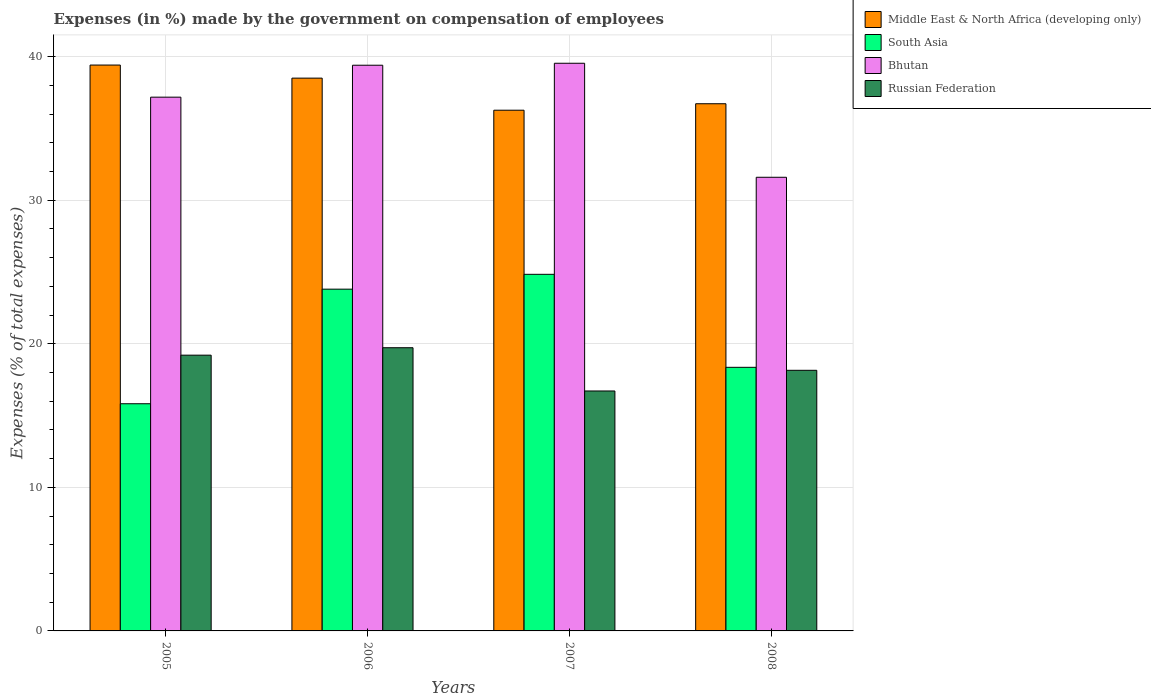How many different coloured bars are there?
Your answer should be very brief. 4. Are the number of bars per tick equal to the number of legend labels?
Give a very brief answer. Yes. Are the number of bars on each tick of the X-axis equal?
Provide a succinct answer. Yes. How many bars are there on the 4th tick from the right?
Your answer should be compact. 4. In how many cases, is the number of bars for a given year not equal to the number of legend labels?
Offer a very short reply. 0. What is the percentage of expenses made by the government on compensation of employees in Russian Federation in 2005?
Make the answer very short. 19.21. Across all years, what is the maximum percentage of expenses made by the government on compensation of employees in Bhutan?
Offer a terse response. 39.54. Across all years, what is the minimum percentage of expenses made by the government on compensation of employees in South Asia?
Offer a very short reply. 15.82. In which year was the percentage of expenses made by the government on compensation of employees in Bhutan maximum?
Make the answer very short. 2007. In which year was the percentage of expenses made by the government on compensation of employees in Bhutan minimum?
Your answer should be very brief. 2008. What is the total percentage of expenses made by the government on compensation of employees in Russian Federation in the graph?
Provide a succinct answer. 73.8. What is the difference between the percentage of expenses made by the government on compensation of employees in Russian Federation in 2006 and that in 2007?
Your answer should be compact. 3.01. What is the difference between the percentage of expenses made by the government on compensation of employees in Russian Federation in 2007 and the percentage of expenses made by the government on compensation of employees in Bhutan in 2005?
Make the answer very short. -20.46. What is the average percentage of expenses made by the government on compensation of employees in Russian Federation per year?
Provide a short and direct response. 18.45. In the year 2006, what is the difference between the percentage of expenses made by the government on compensation of employees in Russian Federation and percentage of expenses made by the government on compensation of employees in Bhutan?
Give a very brief answer. -19.68. In how many years, is the percentage of expenses made by the government on compensation of employees in Russian Federation greater than 30 %?
Give a very brief answer. 0. What is the ratio of the percentage of expenses made by the government on compensation of employees in South Asia in 2006 to that in 2007?
Offer a very short reply. 0.96. Is the difference between the percentage of expenses made by the government on compensation of employees in Russian Federation in 2006 and 2007 greater than the difference between the percentage of expenses made by the government on compensation of employees in Bhutan in 2006 and 2007?
Offer a terse response. Yes. What is the difference between the highest and the second highest percentage of expenses made by the government on compensation of employees in Bhutan?
Offer a terse response. 0.14. What is the difference between the highest and the lowest percentage of expenses made by the government on compensation of employees in Bhutan?
Keep it short and to the point. 7.94. In how many years, is the percentage of expenses made by the government on compensation of employees in South Asia greater than the average percentage of expenses made by the government on compensation of employees in South Asia taken over all years?
Keep it short and to the point. 2. Is it the case that in every year, the sum of the percentage of expenses made by the government on compensation of employees in Middle East & North Africa (developing only) and percentage of expenses made by the government on compensation of employees in South Asia is greater than the sum of percentage of expenses made by the government on compensation of employees in Bhutan and percentage of expenses made by the government on compensation of employees in Russian Federation?
Offer a terse response. No. What does the 1st bar from the left in 2005 represents?
Your response must be concise. Middle East & North Africa (developing only). What does the 2nd bar from the right in 2007 represents?
Ensure brevity in your answer.  Bhutan. How many years are there in the graph?
Your answer should be compact. 4. What is the difference between two consecutive major ticks on the Y-axis?
Your answer should be very brief. 10. Are the values on the major ticks of Y-axis written in scientific E-notation?
Provide a succinct answer. No. Does the graph contain any zero values?
Your response must be concise. No. Does the graph contain grids?
Give a very brief answer. Yes. Where does the legend appear in the graph?
Provide a short and direct response. Top right. How many legend labels are there?
Offer a terse response. 4. How are the legend labels stacked?
Your response must be concise. Vertical. What is the title of the graph?
Provide a succinct answer. Expenses (in %) made by the government on compensation of employees. Does "High income: OECD" appear as one of the legend labels in the graph?
Offer a very short reply. No. What is the label or title of the X-axis?
Offer a very short reply. Years. What is the label or title of the Y-axis?
Ensure brevity in your answer.  Expenses (% of total expenses). What is the Expenses (% of total expenses) in Middle East & North Africa (developing only) in 2005?
Your answer should be compact. 39.41. What is the Expenses (% of total expenses) in South Asia in 2005?
Make the answer very short. 15.82. What is the Expenses (% of total expenses) in Bhutan in 2005?
Your response must be concise. 37.18. What is the Expenses (% of total expenses) in Russian Federation in 2005?
Your answer should be very brief. 19.21. What is the Expenses (% of total expenses) of Middle East & North Africa (developing only) in 2006?
Your response must be concise. 38.5. What is the Expenses (% of total expenses) of South Asia in 2006?
Your answer should be very brief. 23.81. What is the Expenses (% of total expenses) in Bhutan in 2006?
Make the answer very short. 39.4. What is the Expenses (% of total expenses) of Russian Federation in 2006?
Offer a very short reply. 19.73. What is the Expenses (% of total expenses) of Middle East & North Africa (developing only) in 2007?
Make the answer very short. 36.27. What is the Expenses (% of total expenses) of South Asia in 2007?
Offer a very short reply. 24.84. What is the Expenses (% of total expenses) of Bhutan in 2007?
Make the answer very short. 39.54. What is the Expenses (% of total expenses) of Russian Federation in 2007?
Offer a terse response. 16.71. What is the Expenses (% of total expenses) in Middle East & North Africa (developing only) in 2008?
Ensure brevity in your answer.  36.72. What is the Expenses (% of total expenses) in South Asia in 2008?
Make the answer very short. 18.36. What is the Expenses (% of total expenses) in Bhutan in 2008?
Offer a very short reply. 31.6. What is the Expenses (% of total expenses) in Russian Federation in 2008?
Your answer should be compact. 18.15. Across all years, what is the maximum Expenses (% of total expenses) of Middle East & North Africa (developing only)?
Offer a very short reply. 39.41. Across all years, what is the maximum Expenses (% of total expenses) in South Asia?
Your answer should be very brief. 24.84. Across all years, what is the maximum Expenses (% of total expenses) of Bhutan?
Your answer should be very brief. 39.54. Across all years, what is the maximum Expenses (% of total expenses) of Russian Federation?
Provide a short and direct response. 19.73. Across all years, what is the minimum Expenses (% of total expenses) in Middle East & North Africa (developing only)?
Your answer should be very brief. 36.27. Across all years, what is the minimum Expenses (% of total expenses) of South Asia?
Your response must be concise. 15.82. Across all years, what is the minimum Expenses (% of total expenses) in Bhutan?
Provide a short and direct response. 31.6. Across all years, what is the minimum Expenses (% of total expenses) of Russian Federation?
Offer a terse response. 16.71. What is the total Expenses (% of total expenses) in Middle East & North Africa (developing only) in the graph?
Offer a terse response. 150.91. What is the total Expenses (% of total expenses) in South Asia in the graph?
Ensure brevity in your answer.  82.83. What is the total Expenses (% of total expenses) in Bhutan in the graph?
Give a very brief answer. 147.72. What is the total Expenses (% of total expenses) in Russian Federation in the graph?
Ensure brevity in your answer.  73.8. What is the difference between the Expenses (% of total expenses) of Middle East & North Africa (developing only) in 2005 and that in 2006?
Ensure brevity in your answer.  0.91. What is the difference between the Expenses (% of total expenses) in South Asia in 2005 and that in 2006?
Keep it short and to the point. -7.98. What is the difference between the Expenses (% of total expenses) of Bhutan in 2005 and that in 2006?
Provide a short and direct response. -2.23. What is the difference between the Expenses (% of total expenses) in Russian Federation in 2005 and that in 2006?
Your answer should be compact. -0.52. What is the difference between the Expenses (% of total expenses) of Middle East & North Africa (developing only) in 2005 and that in 2007?
Keep it short and to the point. 3.15. What is the difference between the Expenses (% of total expenses) in South Asia in 2005 and that in 2007?
Offer a very short reply. -9.02. What is the difference between the Expenses (% of total expenses) of Bhutan in 2005 and that in 2007?
Make the answer very short. -2.36. What is the difference between the Expenses (% of total expenses) of Russian Federation in 2005 and that in 2007?
Ensure brevity in your answer.  2.49. What is the difference between the Expenses (% of total expenses) in Middle East & North Africa (developing only) in 2005 and that in 2008?
Your answer should be very brief. 2.69. What is the difference between the Expenses (% of total expenses) in South Asia in 2005 and that in 2008?
Make the answer very short. -2.54. What is the difference between the Expenses (% of total expenses) in Bhutan in 2005 and that in 2008?
Your response must be concise. 5.58. What is the difference between the Expenses (% of total expenses) in Russian Federation in 2005 and that in 2008?
Ensure brevity in your answer.  1.05. What is the difference between the Expenses (% of total expenses) in Middle East & North Africa (developing only) in 2006 and that in 2007?
Keep it short and to the point. 2.23. What is the difference between the Expenses (% of total expenses) of South Asia in 2006 and that in 2007?
Ensure brevity in your answer.  -1.03. What is the difference between the Expenses (% of total expenses) in Bhutan in 2006 and that in 2007?
Make the answer very short. -0.14. What is the difference between the Expenses (% of total expenses) in Russian Federation in 2006 and that in 2007?
Your response must be concise. 3.01. What is the difference between the Expenses (% of total expenses) of Middle East & North Africa (developing only) in 2006 and that in 2008?
Your answer should be very brief. 1.78. What is the difference between the Expenses (% of total expenses) of South Asia in 2006 and that in 2008?
Give a very brief answer. 5.44. What is the difference between the Expenses (% of total expenses) in Bhutan in 2006 and that in 2008?
Make the answer very short. 7.8. What is the difference between the Expenses (% of total expenses) in Russian Federation in 2006 and that in 2008?
Your answer should be compact. 1.57. What is the difference between the Expenses (% of total expenses) of Middle East & North Africa (developing only) in 2007 and that in 2008?
Offer a terse response. -0.45. What is the difference between the Expenses (% of total expenses) of South Asia in 2007 and that in 2008?
Offer a terse response. 6.48. What is the difference between the Expenses (% of total expenses) of Bhutan in 2007 and that in 2008?
Make the answer very short. 7.94. What is the difference between the Expenses (% of total expenses) in Russian Federation in 2007 and that in 2008?
Your answer should be very brief. -1.44. What is the difference between the Expenses (% of total expenses) of Middle East & North Africa (developing only) in 2005 and the Expenses (% of total expenses) of South Asia in 2006?
Offer a very short reply. 15.61. What is the difference between the Expenses (% of total expenses) of Middle East & North Africa (developing only) in 2005 and the Expenses (% of total expenses) of Bhutan in 2006?
Give a very brief answer. 0.01. What is the difference between the Expenses (% of total expenses) of Middle East & North Africa (developing only) in 2005 and the Expenses (% of total expenses) of Russian Federation in 2006?
Provide a succinct answer. 19.69. What is the difference between the Expenses (% of total expenses) of South Asia in 2005 and the Expenses (% of total expenses) of Bhutan in 2006?
Offer a very short reply. -23.58. What is the difference between the Expenses (% of total expenses) in South Asia in 2005 and the Expenses (% of total expenses) in Russian Federation in 2006?
Offer a terse response. -3.9. What is the difference between the Expenses (% of total expenses) in Bhutan in 2005 and the Expenses (% of total expenses) in Russian Federation in 2006?
Your answer should be compact. 17.45. What is the difference between the Expenses (% of total expenses) of Middle East & North Africa (developing only) in 2005 and the Expenses (% of total expenses) of South Asia in 2007?
Your answer should be very brief. 14.58. What is the difference between the Expenses (% of total expenses) of Middle East & North Africa (developing only) in 2005 and the Expenses (% of total expenses) of Bhutan in 2007?
Give a very brief answer. -0.13. What is the difference between the Expenses (% of total expenses) of Middle East & North Africa (developing only) in 2005 and the Expenses (% of total expenses) of Russian Federation in 2007?
Offer a terse response. 22.7. What is the difference between the Expenses (% of total expenses) in South Asia in 2005 and the Expenses (% of total expenses) in Bhutan in 2007?
Your response must be concise. -23.72. What is the difference between the Expenses (% of total expenses) in South Asia in 2005 and the Expenses (% of total expenses) in Russian Federation in 2007?
Offer a very short reply. -0.89. What is the difference between the Expenses (% of total expenses) in Bhutan in 2005 and the Expenses (% of total expenses) in Russian Federation in 2007?
Provide a succinct answer. 20.46. What is the difference between the Expenses (% of total expenses) of Middle East & North Africa (developing only) in 2005 and the Expenses (% of total expenses) of South Asia in 2008?
Give a very brief answer. 21.05. What is the difference between the Expenses (% of total expenses) in Middle East & North Africa (developing only) in 2005 and the Expenses (% of total expenses) in Bhutan in 2008?
Give a very brief answer. 7.82. What is the difference between the Expenses (% of total expenses) in Middle East & North Africa (developing only) in 2005 and the Expenses (% of total expenses) in Russian Federation in 2008?
Offer a very short reply. 21.26. What is the difference between the Expenses (% of total expenses) in South Asia in 2005 and the Expenses (% of total expenses) in Bhutan in 2008?
Give a very brief answer. -15.77. What is the difference between the Expenses (% of total expenses) in South Asia in 2005 and the Expenses (% of total expenses) in Russian Federation in 2008?
Your answer should be very brief. -2.33. What is the difference between the Expenses (% of total expenses) of Bhutan in 2005 and the Expenses (% of total expenses) of Russian Federation in 2008?
Offer a very short reply. 19.02. What is the difference between the Expenses (% of total expenses) of Middle East & North Africa (developing only) in 2006 and the Expenses (% of total expenses) of South Asia in 2007?
Your answer should be very brief. 13.66. What is the difference between the Expenses (% of total expenses) of Middle East & North Africa (developing only) in 2006 and the Expenses (% of total expenses) of Bhutan in 2007?
Keep it short and to the point. -1.04. What is the difference between the Expenses (% of total expenses) in Middle East & North Africa (developing only) in 2006 and the Expenses (% of total expenses) in Russian Federation in 2007?
Provide a succinct answer. 21.79. What is the difference between the Expenses (% of total expenses) of South Asia in 2006 and the Expenses (% of total expenses) of Bhutan in 2007?
Your answer should be very brief. -15.73. What is the difference between the Expenses (% of total expenses) of South Asia in 2006 and the Expenses (% of total expenses) of Russian Federation in 2007?
Keep it short and to the point. 7.09. What is the difference between the Expenses (% of total expenses) in Bhutan in 2006 and the Expenses (% of total expenses) in Russian Federation in 2007?
Provide a short and direct response. 22.69. What is the difference between the Expenses (% of total expenses) of Middle East & North Africa (developing only) in 2006 and the Expenses (% of total expenses) of South Asia in 2008?
Your response must be concise. 20.14. What is the difference between the Expenses (% of total expenses) of Middle East & North Africa (developing only) in 2006 and the Expenses (% of total expenses) of Bhutan in 2008?
Ensure brevity in your answer.  6.91. What is the difference between the Expenses (% of total expenses) in Middle East & North Africa (developing only) in 2006 and the Expenses (% of total expenses) in Russian Federation in 2008?
Give a very brief answer. 20.35. What is the difference between the Expenses (% of total expenses) of South Asia in 2006 and the Expenses (% of total expenses) of Bhutan in 2008?
Your answer should be very brief. -7.79. What is the difference between the Expenses (% of total expenses) of South Asia in 2006 and the Expenses (% of total expenses) of Russian Federation in 2008?
Provide a succinct answer. 5.65. What is the difference between the Expenses (% of total expenses) of Bhutan in 2006 and the Expenses (% of total expenses) of Russian Federation in 2008?
Offer a very short reply. 21.25. What is the difference between the Expenses (% of total expenses) of Middle East & North Africa (developing only) in 2007 and the Expenses (% of total expenses) of South Asia in 2008?
Offer a terse response. 17.91. What is the difference between the Expenses (% of total expenses) of Middle East & North Africa (developing only) in 2007 and the Expenses (% of total expenses) of Bhutan in 2008?
Give a very brief answer. 4.67. What is the difference between the Expenses (% of total expenses) in Middle East & North Africa (developing only) in 2007 and the Expenses (% of total expenses) in Russian Federation in 2008?
Keep it short and to the point. 18.12. What is the difference between the Expenses (% of total expenses) of South Asia in 2007 and the Expenses (% of total expenses) of Bhutan in 2008?
Your answer should be compact. -6.76. What is the difference between the Expenses (% of total expenses) in South Asia in 2007 and the Expenses (% of total expenses) in Russian Federation in 2008?
Offer a very short reply. 6.69. What is the difference between the Expenses (% of total expenses) in Bhutan in 2007 and the Expenses (% of total expenses) in Russian Federation in 2008?
Provide a succinct answer. 21.39. What is the average Expenses (% of total expenses) in Middle East & North Africa (developing only) per year?
Ensure brevity in your answer.  37.73. What is the average Expenses (% of total expenses) of South Asia per year?
Offer a very short reply. 20.71. What is the average Expenses (% of total expenses) of Bhutan per year?
Give a very brief answer. 36.93. What is the average Expenses (% of total expenses) in Russian Federation per year?
Your answer should be compact. 18.45. In the year 2005, what is the difference between the Expenses (% of total expenses) in Middle East & North Africa (developing only) and Expenses (% of total expenses) in South Asia?
Make the answer very short. 23.59. In the year 2005, what is the difference between the Expenses (% of total expenses) in Middle East & North Africa (developing only) and Expenses (% of total expenses) in Bhutan?
Your response must be concise. 2.24. In the year 2005, what is the difference between the Expenses (% of total expenses) in Middle East & North Africa (developing only) and Expenses (% of total expenses) in Russian Federation?
Provide a succinct answer. 20.21. In the year 2005, what is the difference between the Expenses (% of total expenses) of South Asia and Expenses (% of total expenses) of Bhutan?
Give a very brief answer. -21.35. In the year 2005, what is the difference between the Expenses (% of total expenses) of South Asia and Expenses (% of total expenses) of Russian Federation?
Keep it short and to the point. -3.38. In the year 2005, what is the difference between the Expenses (% of total expenses) in Bhutan and Expenses (% of total expenses) in Russian Federation?
Your response must be concise. 17.97. In the year 2006, what is the difference between the Expenses (% of total expenses) of Middle East & North Africa (developing only) and Expenses (% of total expenses) of South Asia?
Keep it short and to the point. 14.7. In the year 2006, what is the difference between the Expenses (% of total expenses) in Middle East & North Africa (developing only) and Expenses (% of total expenses) in Bhutan?
Offer a terse response. -0.9. In the year 2006, what is the difference between the Expenses (% of total expenses) of Middle East & North Africa (developing only) and Expenses (% of total expenses) of Russian Federation?
Offer a very short reply. 18.78. In the year 2006, what is the difference between the Expenses (% of total expenses) of South Asia and Expenses (% of total expenses) of Bhutan?
Your answer should be very brief. -15.6. In the year 2006, what is the difference between the Expenses (% of total expenses) in South Asia and Expenses (% of total expenses) in Russian Federation?
Keep it short and to the point. 4.08. In the year 2006, what is the difference between the Expenses (% of total expenses) in Bhutan and Expenses (% of total expenses) in Russian Federation?
Keep it short and to the point. 19.68. In the year 2007, what is the difference between the Expenses (% of total expenses) in Middle East & North Africa (developing only) and Expenses (% of total expenses) in South Asia?
Provide a short and direct response. 11.43. In the year 2007, what is the difference between the Expenses (% of total expenses) in Middle East & North Africa (developing only) and Expenses (% of total expenses) in Bhutan?
Offer a terse response. -3.27. In the year 2007, what is the difference between the Expenses (% of total expenses) of Middle East & North Africa (developing only) and Expenses (% of total expenses) of Russian Federation?
Keep it short and to the point. 19.56. In the year 2007, what is the difference between the Expenses (% of total expenses) of South Asia and Expenses (% of total expenses) of Bhutan?
Offer a terse response. -14.7. In the year 2007, what is the difference between the Expenses (% of total expenses) in South Asia and Expenses (% of total expenses) in Russian Federation?
Provide a short and direct response. 8.13. In the year 2007, what is the difference between the Expenses (% of total expenses) of Bhutan and Expenses (% of total expenses) of Russian Federation?
Make the answer very short. 22.83. In the year 2008, what is the difference between the Expenses (% of total expenses) in Middle East & North Africa (developing only) and Expenses (% of total expenses) in South Asia?
Provide a succinct answer. 18.36. In the year 2008, what is the difference between the Expenses (% of total expenses) in Middle East & North Africa (developing only) and Expenses (% of total expenses) in Bhutan?
Offer a very short reply. 5.12. In the year 2008, what is the difference between the Expenses (% of total expenses) of Middle East & North Africa (developing only) and Expenses (% of total expenses) of Russian Federation?
Offer a very short reply. 18.57. In the year 2008, what is the difference between the Expenses (% of total expenses) of South Asia and Expenses (% of total expenses) of Bhutan?
Provide a short and direct response. -13.24. In the year 2008, what is the difference between the Expenses (% of total expenses) of South Asia and Expenses (% of total expenses) of Russian Federation?
Provide a succinct answer. 0.21. In the year 2008, what is the difference between the Expenses (% of total expenses) in Bhutan and Expenses (% of total expenses) in Russian Federation?
Keep it short and to the point. 13.45. What is the ratio of the Expenses (% of total expenses) in Middle East & North Africa (developing only) in 2005 to that in 2006?
Your answer should be compact. 1.02. What is the ratio of the Expenses (% of total expenses) in South Asia in 2005 to that in 2006?
Ensure brevity in your answer.  0.66. What is the ratio of the Expenses (% of total expenses) in Bhutan in 2005 to that in 2006?
Keep it short and to the point. 0.94. What is the ratio of the Expenses (% of total expenses) of Russian Federation in 2005 to that in 2006?
Offer a very short reply. 0.97. What is the ratio of the Expenses (% of total expenses) in Middle East & North Africa (developing only) in 2005 to that in 2007?
Offer a very short reply. 1.09. What is the ratio of the Expenses (% of total expenses) of South Asia in 2005 to that in 2007?
Offer a terse response. 0.64. What is the ratio of the Expenses (% of total expenses) in Bhutan in 2005 to that in 2007?
Your answer should be very brief. 0.94. What is the ratio of the Expenses (% of total expenses) of Russian Federation in 2005 to that in 2007?
Provide a succinct answer. 1.15. What is the ratio of the Expenses (% of total expenses) in Middle East & North Africa (developing only) in 2005 to that in 2008?
Offer a terse response. 1.07. What is the ratio of the Expenses (% of total expenses) in South Asia in 2005 to that in 2008?
Provide a succinct answer. 0.86. What is the ratio of the Expenses (% of total expenses) in Bhutan in 2005 to that in 2008?
Offer a very short reply. 1.18. What is the ratio of the Expenses (% of total expenses) in Russian Federation in 2005 to that in 2008?
Give a very brief answer. 1.06. What is the ratio of the Expenses (% of total expenses) of Middle East & North Africa (developing only) in 2006 to that in 2007?
Ensure brevity in your answer.  1.06. What is the ratio of the Expenses (% of total expenses) in South Asia in 2006 to that in 2007?
Your answer should be compact. 0.96. What is the ratio of the Expenses (% of total expenses) in Russian Federation in 2006 to that in 2007?
Your answer should be compact. 1.18. What is the ratio of the Expenses (% of total expenses) of Middle East & North Africa (developing only) in 2006 to that in 2008?
Provide a succinct answer. 1.05. What is the ratio of the Expenses (% of total expenses) of South Asia in 2006 to that in 2008?
Offer a very short reply. 1.3. What is the ratio of the Expenses (% of total expenses) of Bhutan in 2006 to that in 2008?
Your answer should be very brief. 1.25. What is the ratio of the Expenses (% of total expenses) in Russian Federation in 2006 to that in 2008?
Your answer should be compact. 1.09. What is the ratio of the Expenses (% of total expenses) of South Asia in 2007 to that in 2008?
Ensure brevity in your answer.  1.35. What is the ratio of the Expenses (% of total expenses) of Bhutan in 2007 to that in 2008?
Ensure brevity in your answer.  1.25. What is the ratio of the Expenses (% of total expenses) of Russian Federation in 2007 to that in 2008?
Your answer should be compact. 0.92. What is the difference between the highest and the second highest Expenses (% of total expenses) of Middle East & North Africa (developing only)?
Offer a very short reply. 0.91. What is the difference between the highest and the second highest Expenses (% of total expenses) of South Asia?
Give a very brief answer. 1.03. What is the difference between the highest and the second highest Expenses (% of total expenses) in Bhutan?
Your answer should be very brief. 0.14. What is the difference between the highest and the second highest Expenses (% of total expenses) in Russian Federation?
Your answer should be compact. 0.52. What is the difference between the highest and the lowest Expenses (% of total expenses) in Middle East & North Africa (developing only)?
Keep it short and to the point. 3.15. What is the difference between the highest and the lowest Expenses (% of total expenses) in South Asia?
Your response must be concise. 9.02. What is the difference between the highest and the lowest Expenses (% of total expenses) in Bhutan?
Your answer should be very brief. 7.94. What is the difference between the highest and the lowest Expenses (% of total expenses) in Russian Federation?
Give a very brief answer. 3.01. 